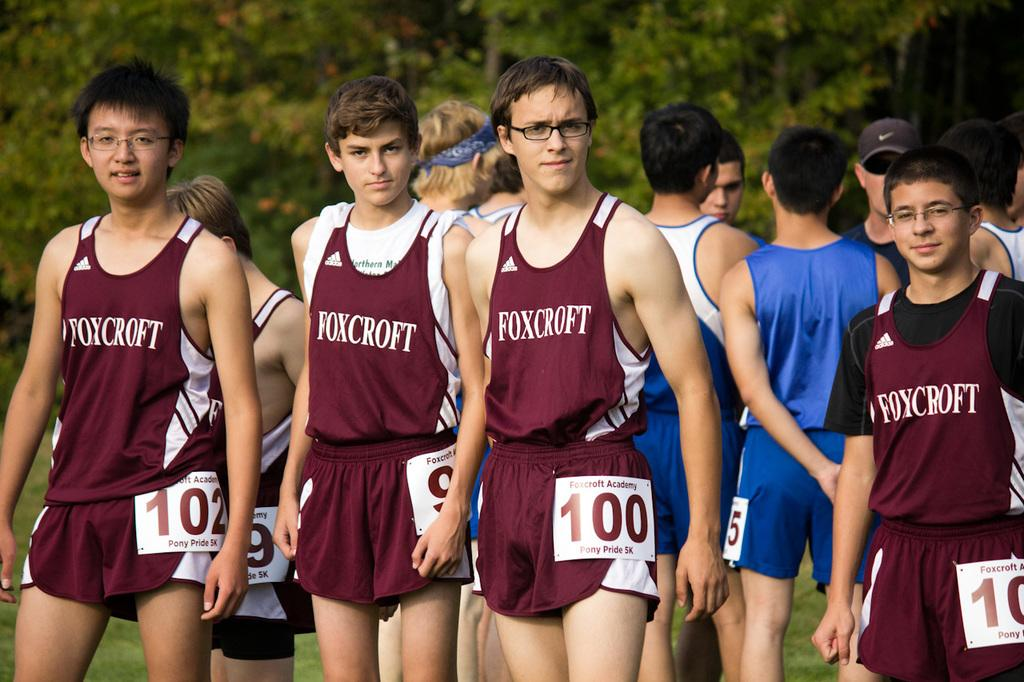<image>
Offer a succinct explanation of the picture presented. A number of young men wear shirts that say Foxcroft. 